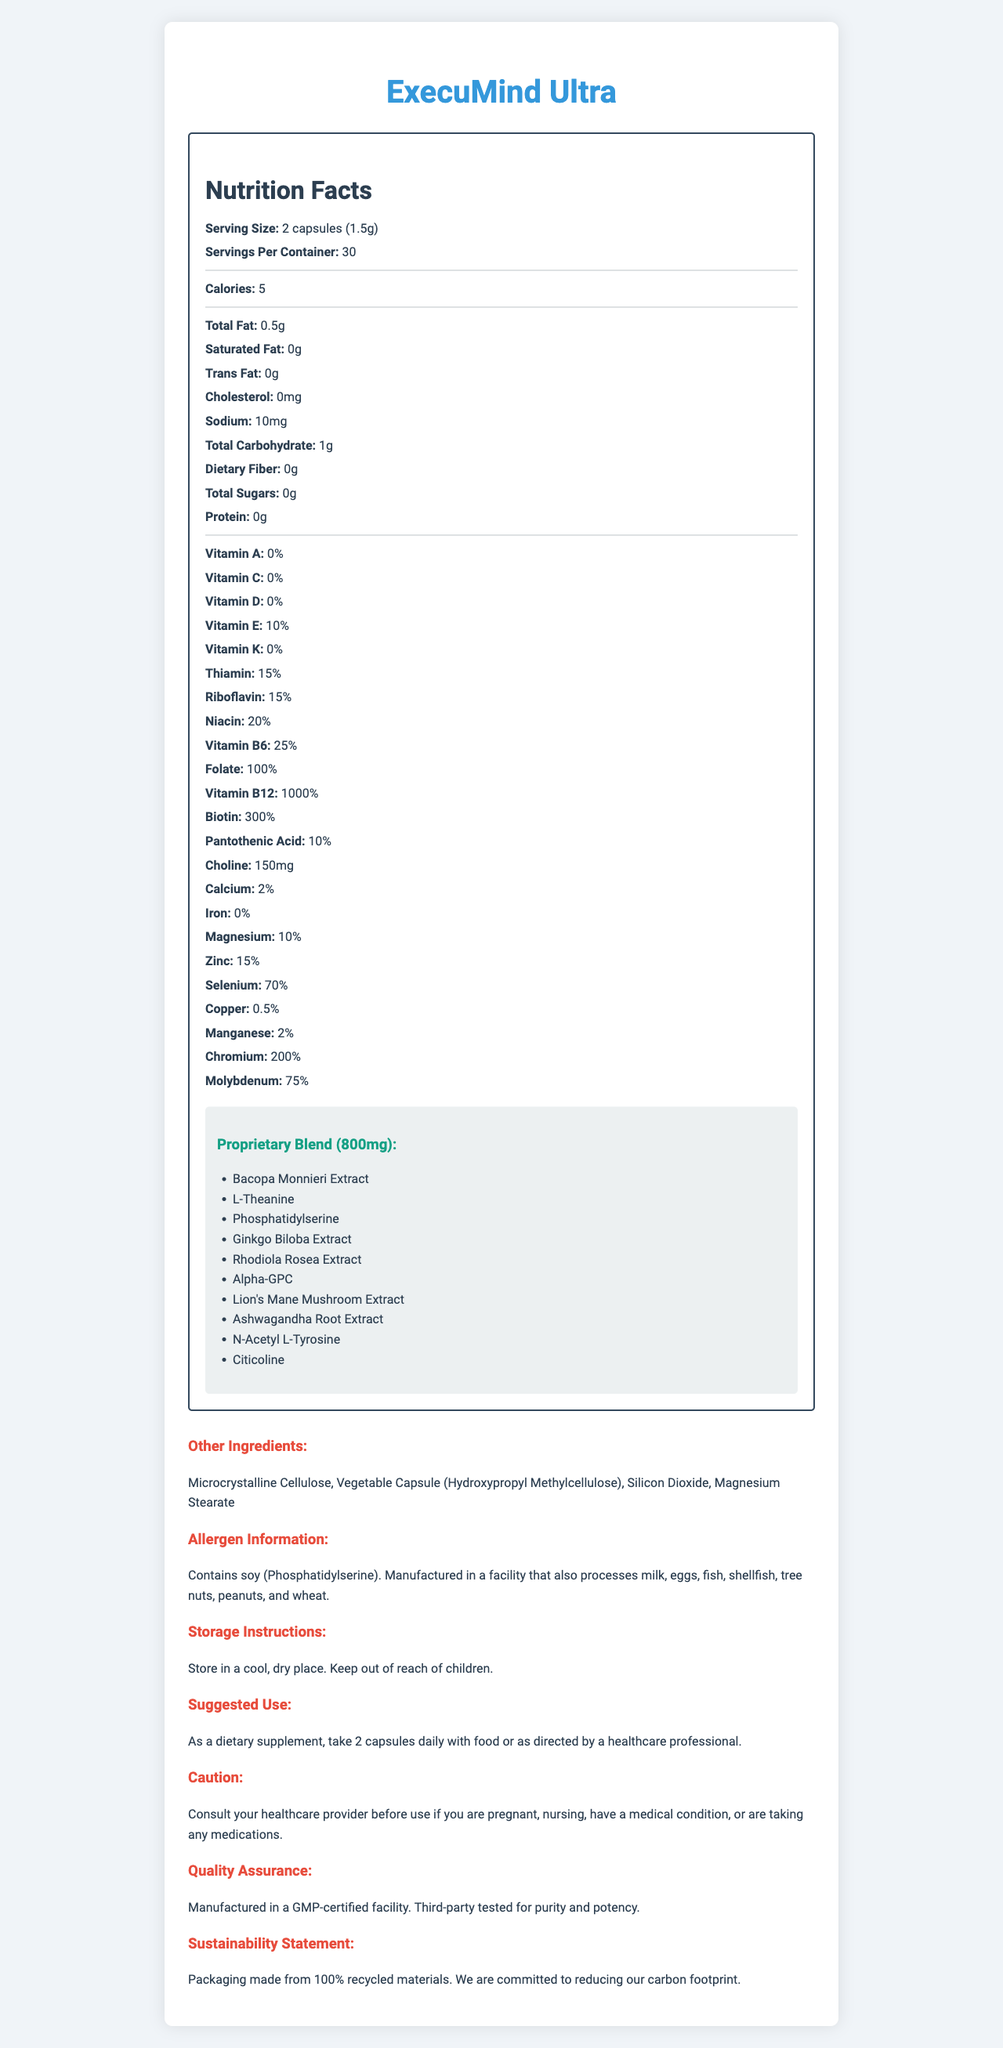What is the serving size of ExecuMind Ultra? The serving size is clearly mentioned under the "Serving Size" section in the Nutrition Facts.
Answer: 2 capsules (1.5g) How many servings per container? The document states "Servings Per Container" as 30.
Answer: 30 What is the total calorie content per serving? The "Calories" section lists the total calories per serving as 5.
Answer: 5 calories How much sodium does each serving contain? The sodium content per serving is listed as 10mg in the Nutrition Facts section.
Answer: 10mg Which ingredient in the proprietary blend is known for its stress-relieving properties? Ashwagandha is widely recognized for its stress-relieving and adaptogenic properties.
Answer: Ashwagandha Root Extract Which vitamins are provided in highest amounts relative to their daily value percentages? Vitamin B12 is listed with a percentage of 1000% of the daily value.
Answer: Vitamin B12 How much Vitamin E is present per serving? The document lists Vitamin E as 10% of the daily value per serving.
Answer: 10% Which of the following is an ingredient in the proprietary blend? A. Aspartame B. Phosphatidylserine C. Beetroot Powder The proprietary blend includes Phosphatidylserine but does not include Aspartame or Beetroot Powder.
Answer: B. Phosphatidylserine How many ingredients are in the proprietary blend? A. 5 B. 7 C. 10 The proprietary blend includes 10 ingredients, as listed in the document.
Answer: C. 10 Does the supplement contain any protein? Under the "Protein" section, it is mentioned that the supplement contains 0g of protein.
Answer: No Is the packaging of ExecuMind Ultra eco-friendly? The sustainability statement indicates that packaging is made from 100% recycled materials.
Answer: Yes Summarize the main information provided in the document. The document includes both numerical and ingredient details for each serving, information on allergens, storage instructions, suggested use, and quality and sustainability assurances.
Answer: The Nutrition Facts label for ExecuMind Ultra provides detailed nutritional information for a brain-boosting supplement tailored to improve cognitive performance. Each serving consists of 2 capsules (1.5g) and contains a variety of vitamins, minerals, and a proprietary blend of ingredients aimed at enhancing brain function. The product is manufactured in a GMP-certified facility, third-party tested for purity and potency, and packaged using sustainable materials. How much magnesium is present per serving? The document lists magnesium as 10% of the daily value per serving.
Answer: 10% What type of capsule is used for this supplement? The document lists the capsule type under "Other Ingredients."
Answer: Vegetable Capsule (Hydroxypropyl Methylcellulose) Where is the product manufactured? The manufacturing location is indicated as a GMP-certified facility under the "Quality Assurance" section.
Answer: Manufactured in a GMP-certified facility Who should consult their healthcare provider before using ExecuMind Ultra? The "Caution" section advises these individuals to consult their healthcare provider before use.
Answer: Individuals who are pregnant, nursing, have a medical condition, or are taking any medications. How many different vitamins are listed in the Nutrition Facts? The document lists 10 different vitamins: Vitamin A, Vitamin C, Vitamin D, Vitamin E, Thiamin, Riboflavin, Niacin, Vitamin B6, Folate, and Vitamin B12.
Answer: 10 Is there sufficient information to determine the exact amounts of individual proprietary blend ingredients? The document only provides the total weight of the proprietary blend (800mg) and lists the ingredients, but does not provide the exact amounts for each ingredient in the blend.
Answer: No 